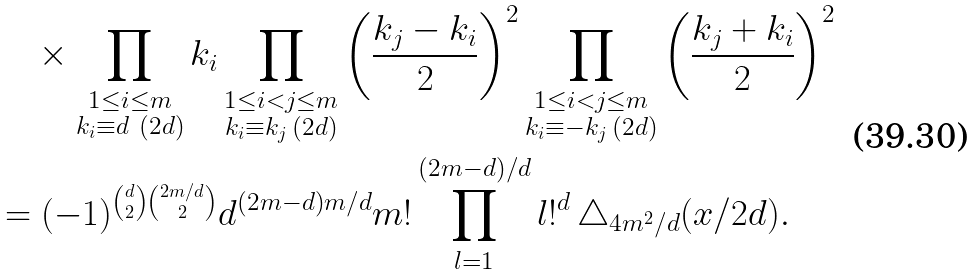<formula> <loc_0><loc_0><loc_500><loc_500>& \quad \times \prod _ { \substack { 1 \leq i \leq m \\ k _ { i } \equiv d \ ( 2 d ) } } k _ { i } \prod _ { \substack { 1 \leq i < j \leq m \\ k _ { i } \equiv k _ { j } \, ( 2 d ) } } { \left ( \frac { k _ { j } - k _ { i } } { 2 } \right ) ^ { 2 } } \prod _ { \substack { 1 \leq i < j \leq m \\ k _ { i } \equiv - k _ { j } \, ( 2 d ) } } { \left ( \frac { k _ { j } + k _ { i } } { 2 } \right ) ^ { 2 } } \\ & = ( - 1 ) ^ { \binom { d } { 2 } \binom { 2 m / d } 2 } d ^ { ( 2 m - d ) m / d } m ! \prod _ { l = 1 } ^ { ( 2 m - d ) / d } l ! ^ { d } \, \triangle _ { 4 m ^ { 2 } / d } ( x / 2 d ) .</formula> 